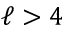Convert formula to latex. <formula><loc_0><loc_0><loc_500><loc_500>\ell > 4</formula> 